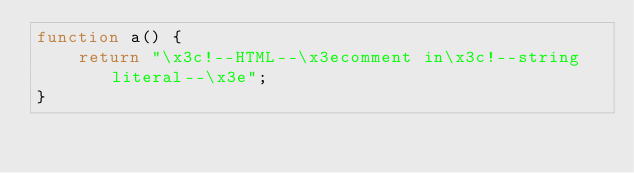<code> <loc_0><loc_0><loc_500><loc_500><_JavaScript_>function a() {
    return "\x3c!--HTML--\x3ecomment in\x3c!--string literal--\x3e";
}
</code> 